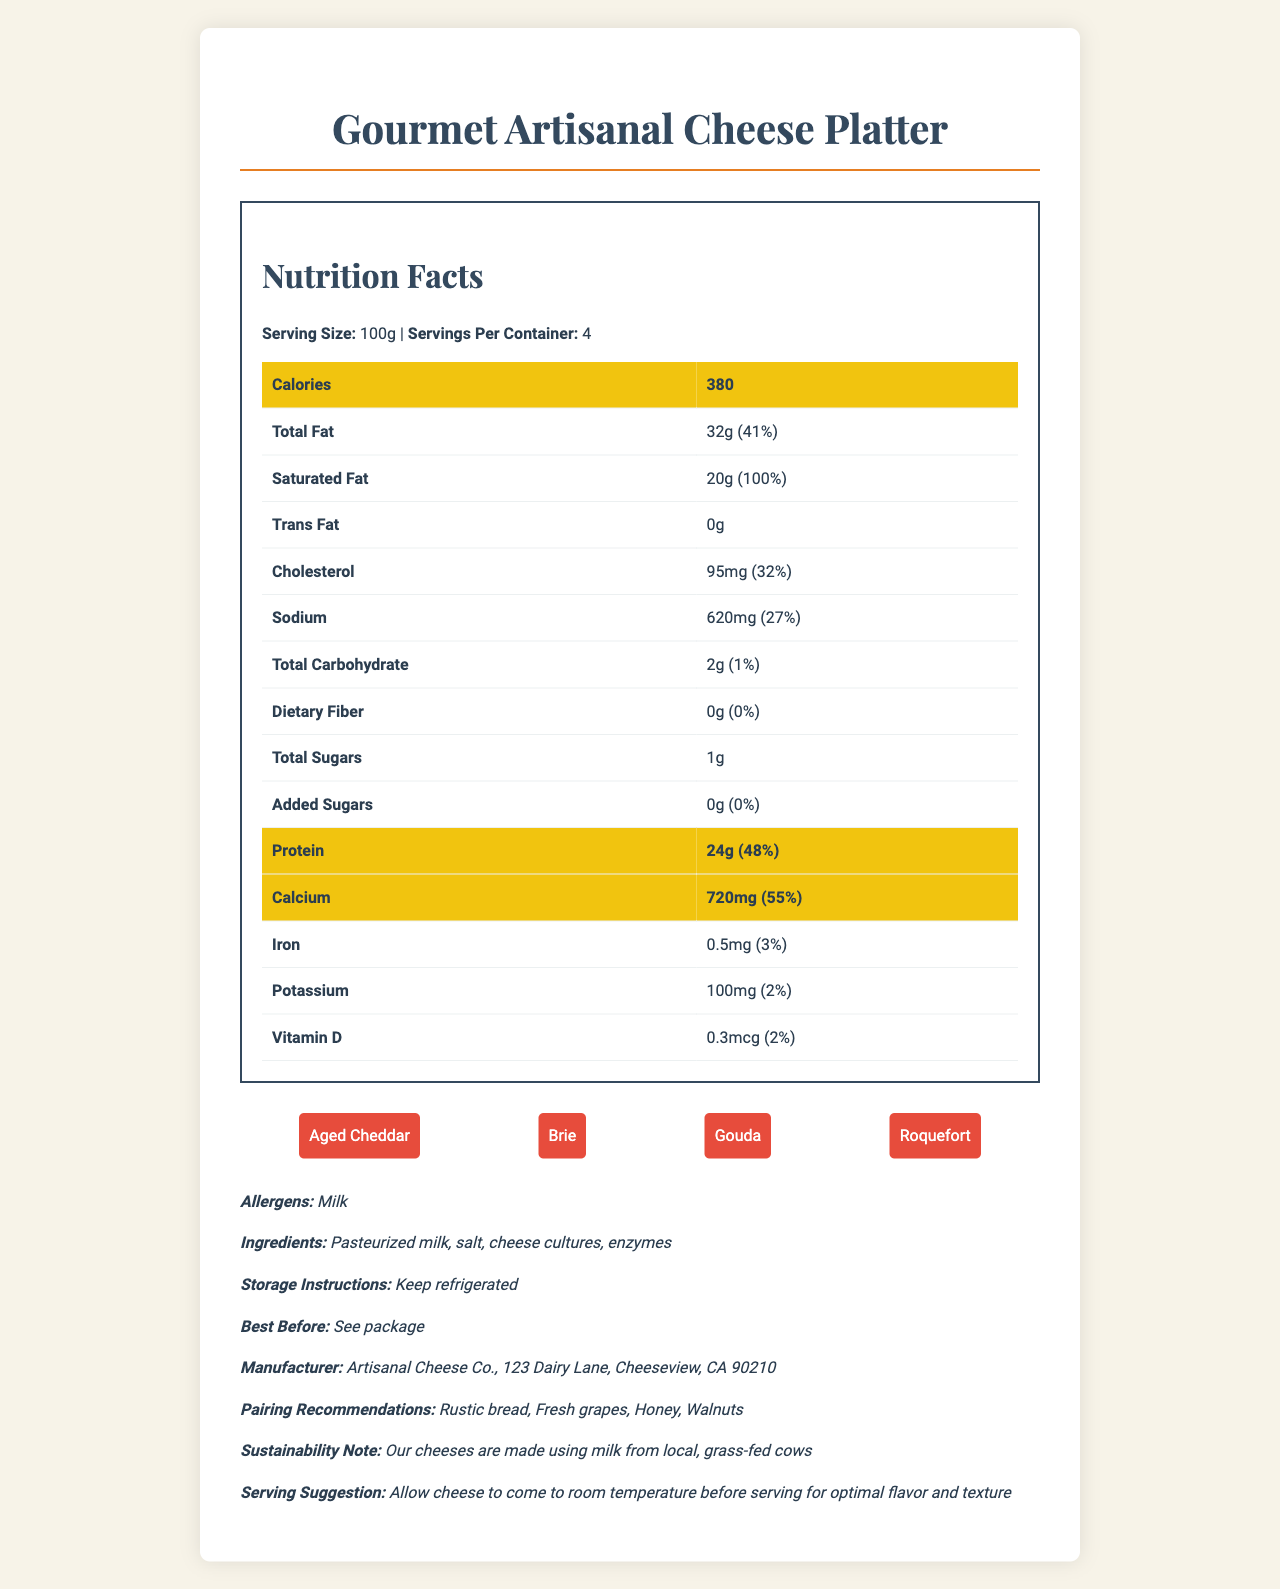what is the serving size? The serving size is listed at the top of the Nutrition Facts section, indicating it is 100g.
Answer: 100g how many servings per container are there? The number of servings per container is provided in the Nutrition Facts section, showing there are 4 servings.
Answer: 4 how many calories are in one serving? The calorie content per serving is highlighted as the first item in the Nutrition Facts section, which is 380 calories.
Answer: 380 what is the amount of protein per serving? The Nutrition Facts section lists the protein content per serving as 24g.
Answer: 24g how much calcium is in one serving of the cheese platter? The amount of calcium per serving is 720mg, as indicated in the Nutrition Facts section.
Answer: 720mg what is the percent daily value of saturated fat? The Nutrition Facts section states that the percent daily value for saturated fat is 100%.
Answer: 100% which type of cheese is NOT part of the platter? A. Mozzarella B. Aged Cheddar C. Brie D. Gouda The listed cheeses are Aged Cheddar, Brie, Gouda, and Roquefort. Mozzarella is not included.
Answer: A how many grams of total fat are there in each serving? The amount of total fat per serving is listed as 32g in the Nutrition Facts section.
Answer: 32g does the cheese platter contain any dietary fiber? The Nutrition Facts section shows that the dietary fiber amount is 0g.
Answer: No what is the paired recommendation provided for the cheese platter? The pairing recommendations section lists rustic bread, fresh grapes, honey, and walnuts.
Answer: Rustic bread, fresh grapes, honey, walnuts summarize the main idea of the document. The summary entails various sections including nutrition facts, cheese types included, instructions, and pairing recommendations. The document highlights the nutritional benefits and guides on how to best enjoy the cheese platter.
Answer: The document provides a detailed nutrition facts label for a gourmet artisanal cheese platter, which includes information on serving size, nutritional content, types of cheese, ingredients, allergens, storage instructions, and pairing recommendations. The focus is on the high calcium and protein content, sustainability notes, and serving suggestions for optimal enjoyment. what are the total sugars per serving? The amount of total sugars per serving is listed as 1g in the Nutrition Facts section.
Answer: 1g does the cheese platter have any added sugars? The Nutrition Facts section reports that the amount of added sugars is 0g, indicating there are no added sugars.
Answer: No which component has the highest percent daily value? I. Saturated Fat II. Calcium III. Cholesterol IV. Protein Saturated fat has the highest percent daily value at 100%, as detailed in the Nutrition Facts section.
Answer: I what allergens are present in the cheese platter? The allergens section states that milk is the allergen present.
Answer: Milk what is the amount of cholesterol per serving? The Nutrition Facts section lists cholesterol as being 95mg per serving.
Answer: 95mg what are the sustainability notes mentioned? The sustainability note section mentions that the cheeses are produced using milk from local, grass-fed cows.
Answer: Our cheeses are made using milk from local, grass-fed cows what is the best before date? The document directs readers to see the package for the best before date, indicating it is not explicitly written on the document.
Answer: See package how should the cheese be stored? The storage instructions recommend keeping the cheese refrigerated.
Answer: Keep refrigerated what is the manufacturer's address? The provided manufacturer's information states the address as Artisanal Cheese Co., 123 Dairy Lane, Cheeseview, CA 90210.
Answer: Artisanal Cheese Co., 123 Dairy Lane, Cheeseview, CA 90210 how much potassium is in the cheese platter? According to the Nutrition Facts, there is 100mg of potassium per serving in the cheese platter.
Answer: 100mg how many grams of trans fat does the cheese platter contain? The document states that the trans fat amount is 0g per serving.
Answer: 0g is the cheese platter gluten-free? The document does not specify whether the cheese platter is gluten-free, only the list of allergens (milk) is provided.
Answer: Not enough information 